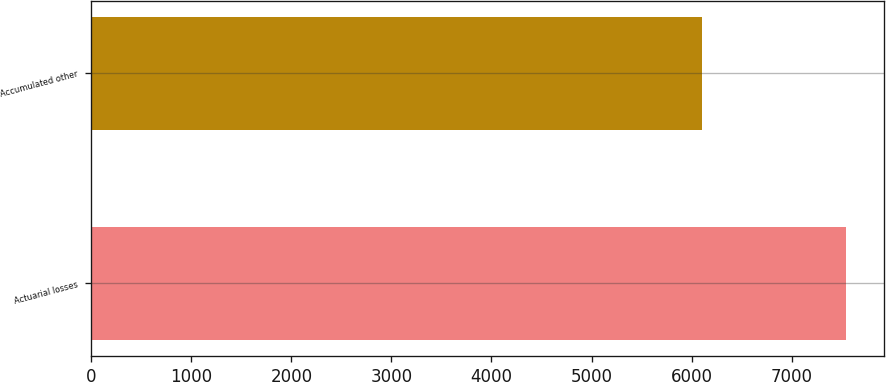<chart> <loc_0><loc_0><loc_500><loc_500><bar_chart><fcel>Actuarial losses<fcel>Accumulated other<nl><fcel>7543<fcel>6104<nl></chart> 